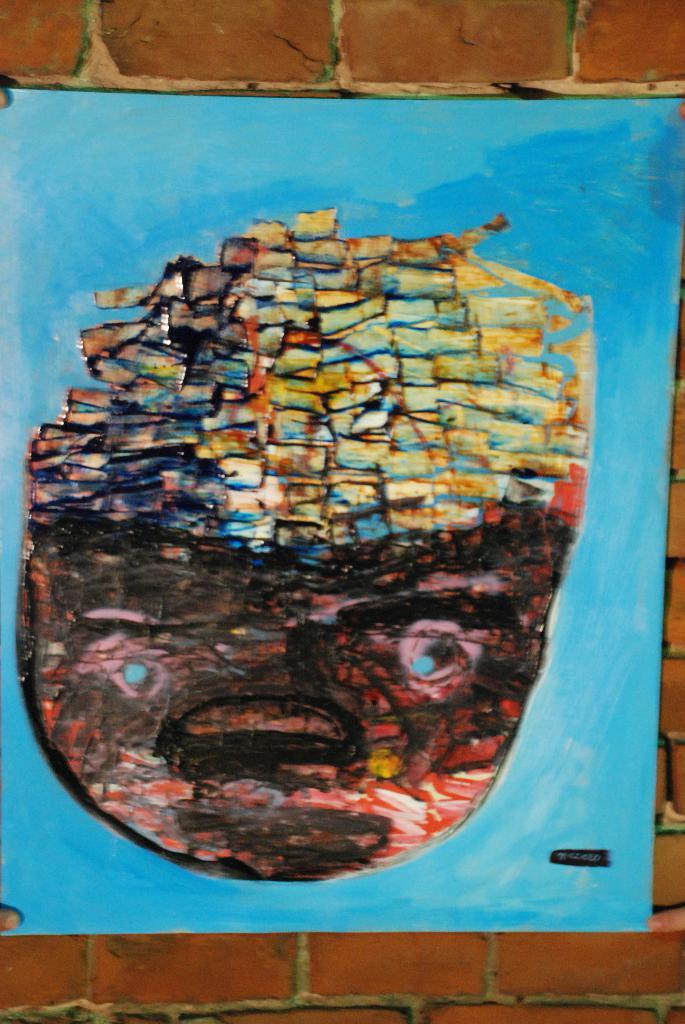What is the main subject of the image? The main subject of the image is a painted chart. Where is the chart located in the image? The chart is in the center of the image. On what surface is the chart placed? The chart is placed on a wall. What type of insurance policy is being advertised on the chart in the image? There is no insurance policy being advertised on the chart in the image; it is a painted chart with no text or images related to insurance. 